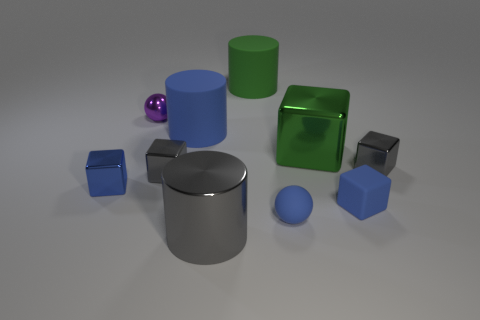There is a green thing that is in front of the blue cylinder; what material is it?
Ensure brevity in your answer.  Metal. Does the sphere that is in front of the purple shiny thing have the same material as the blue cube right of the purple shiny thing?
Your answer should be very brief. Yes. Is the number of blue rubber cylinders that are to the right of the large green shiny object the same as the number of small blue matte blocks to the left of the big shiny cylinder?
Offer a very short reply. Yes. What number of tiny gray things have the same material as the green block?
Ensure brevity in your answer.  2. There is a tiny metallic object that is the same color as the small matte sphere; what is its shape?
Ensure brevity in your answer.  Cube. What size is the green thing left of the tiny matte ball that is right of the purple shiny thing?
Your response must be concise. Large. There is a gray shiny object in front of the blue shiny cube; does it have the same shape as the large metal object behind the large metallic cylinder?
Provide a succinct answer. No. Is the number of blue rubber balls in front of the green rubber cylinder the same as the number of green cylinders?
Your answer should be very brief. Yes. What color is the other object that is the same shape as the small purple object?
Your answer should be compact. Blue. Does the ball behind the small matte ball have the same material as the large gray object?
Your response must be concise. Yes. 